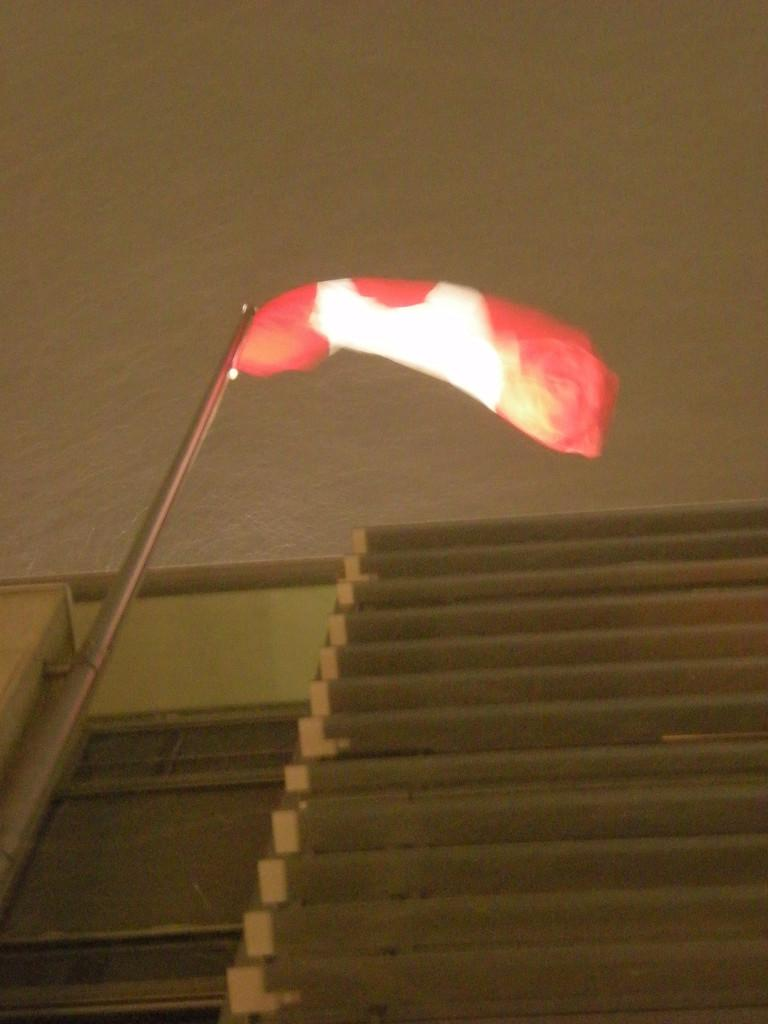What is the main object in the image? There is a metal rod in the image. What is the color of the other object in the image? There is a red-colored thing in the image. How many toes can be seen on the metal rod in the image? There are no toes present in the image, as it features a metal rod and a red-colored object. 